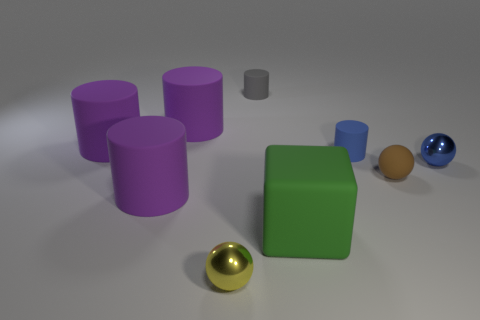Subtract all purple cylinders. How many were subtracted if there are1purple cylinders left? 2 Subtract all blue cubes. How many purple cylinders are left? 3 Subtract all blocks. How many objects are left? 8 Add 5 small matte objects. How many small matte objects are left? 8 Add 1 yellow balls. How many yellow balls exist? 2 Subtract 0 red balls. How many objects are left? 9 Subtract all yellow balls. Subtract all brown objects. How many objects are left? 7 